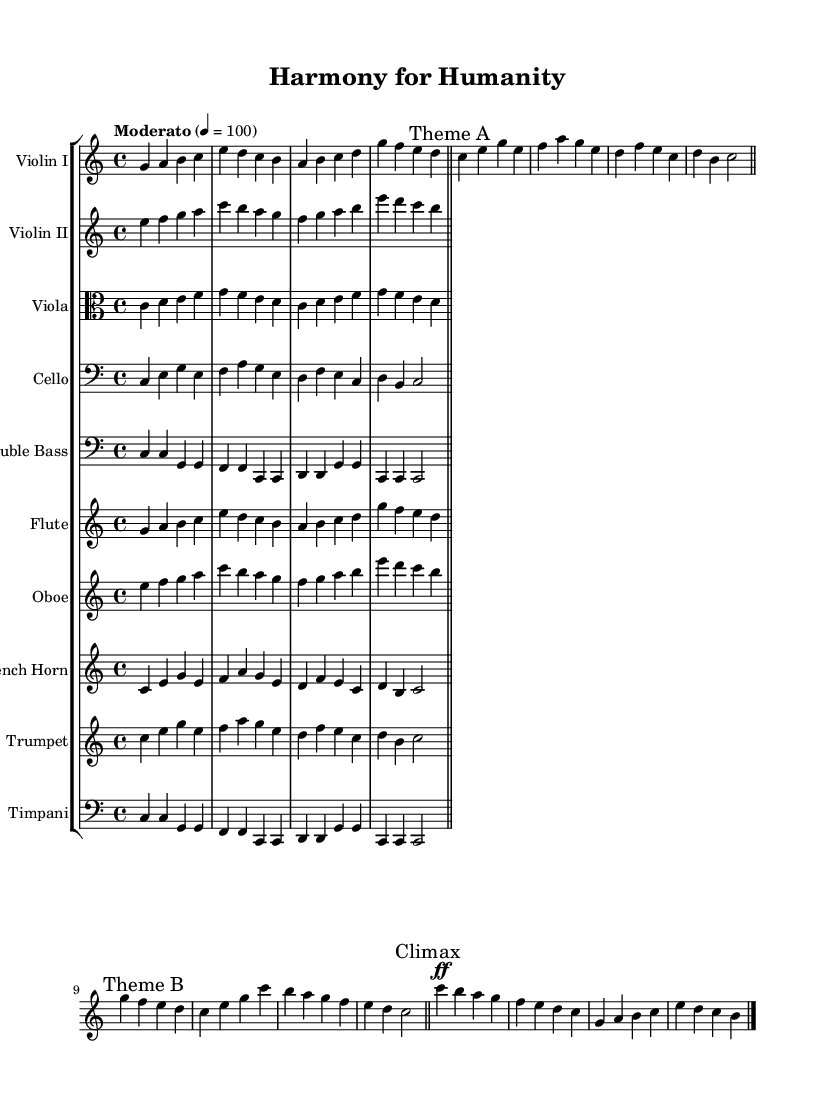What is the key signature of this music? The key signature is C major, which has no sharps or flats indicated on the staff.
Answer: C major What is the time signature of this piece? The time signature is indicated at the beginning of the score and is marked as 4/4, meaning there are four beats in each measure.
Answer: 4/4 What tempo marking is given for this piece? The tempo marking provided states "Moderato" with a metronome marking of 100 beats per minute, indicating a moderate pace.
Answer: Moderato, 100 How many different instruments are included in the score? By counting each staff in the staff group, there are ten staves representing different instruments, including strings and woodwinds.
Answer: 10 Which instrument plays the climax section? The climax section is marked in the music and is written for The Violin I part, which features the highest melodies and dynamic markings.
Answer: Violin I What is the dynamic marking used in the climax? The climax section has a dynamic marking of "fortissimo (ff)," indicating it should be played very loudly, contributing to the overall impact of the music.
Answer: fortissimo 